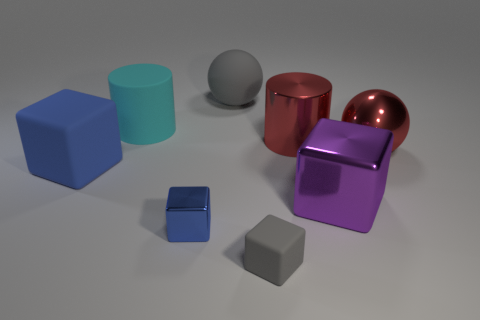Are there any green metallic balls? After examining the image, I can confirm there are no green metallic balls present. What we do see are geometric shapes with various colors and textures. There's a cylindrical shape that is closer to teal rather than green, and a spherical object that is gray, but no green metallic balls. 